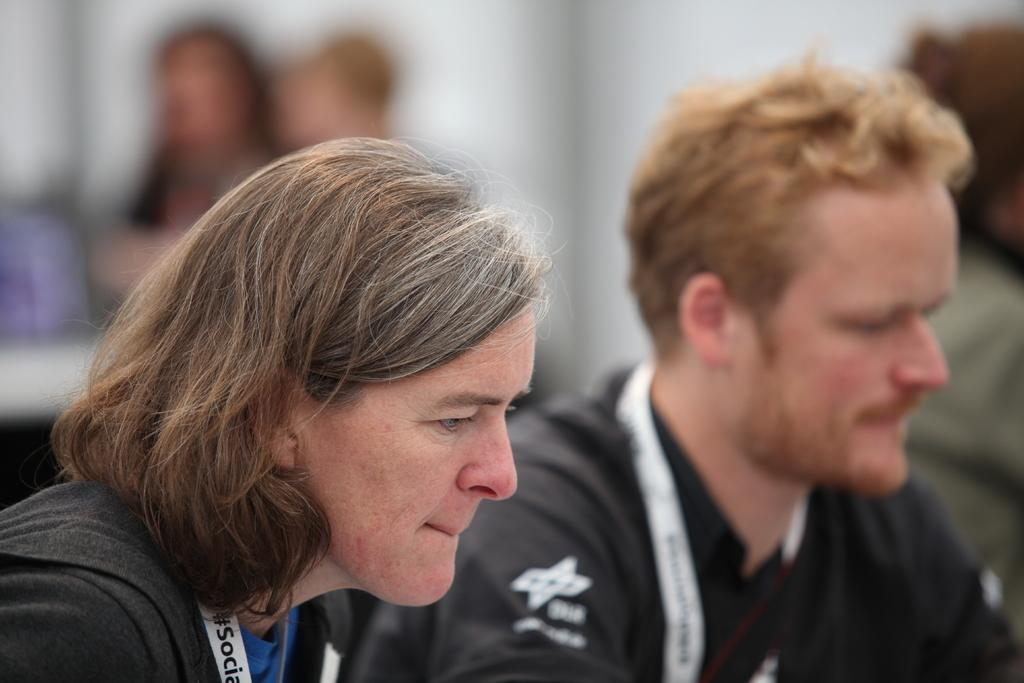What can be seen in the image in terms of people? There is a group of people in the image. Can you describe any specific person in the group? There is a woman with long hair in the image. What is the woman wearing that might be used for identification? The woman is wearing an ID card. Is there anyone in the group wearing a specific color? Yes, there is a person wearing a black dress in the image. What type of egg is being used in the attempt to hear the conversation in the image? There is no egg or attempt to hear a conversation present in the image. 